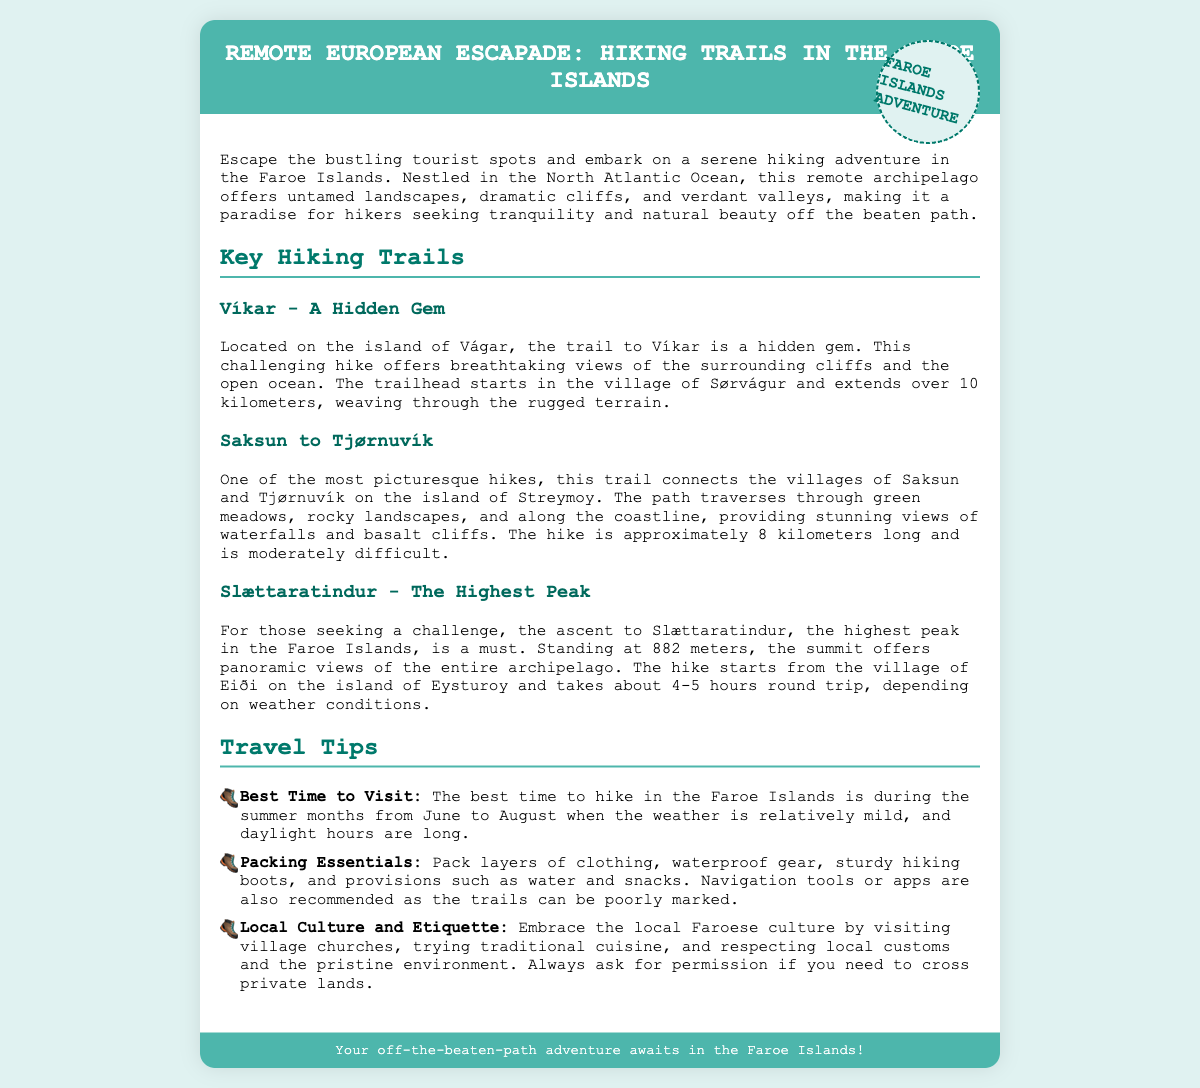What is the location of the trail to Víkar? The trail to Víkar is located on the island of Vágar.
Answer: Vágar How long is the Saksun to Tjørnuvík hike? The Saksun to Tjørnuvík hike is approximately 8 kilometers long.
Answer: 8 kilometers What is the highest peak in the Faroe Islands? The highest peak in the Faroe Islands is Slættaratindur.
Answer: Slættaratindur What is the best time to visit for hiking? The best time to hike in the Faroe Islands is during the summer months from June to August.
Answer: June to August What type of gear is recommended to pack? It is recommended to pack layers of clothing, waterproof gear, and sturdy hiking boots.
Answer: Layers of clothing, waterproof gear, sturdy hiking boots What is a key feature of the Slættaratindur hike? The key feature of the Slættaratindur hike is the panoramic views of the entire archipelago.
Answer: Panoramic views What cultural aspect should hikers embrace? Hikers should embrace the local Faroese culture by visiting village churches and trying traditional cuisine.
Answer: Visiting village churches and trying traditional cuisine How long does the hike to Slættaratindur take? The hike to Slættaratindur takes about 4-5 hours round trip.
Answer: 4-5 hours What is a primary concern regarding trail navigation? A primary concern regarding trail navigation is that the trails can be poorly marked.
Answer: Poorly marked 